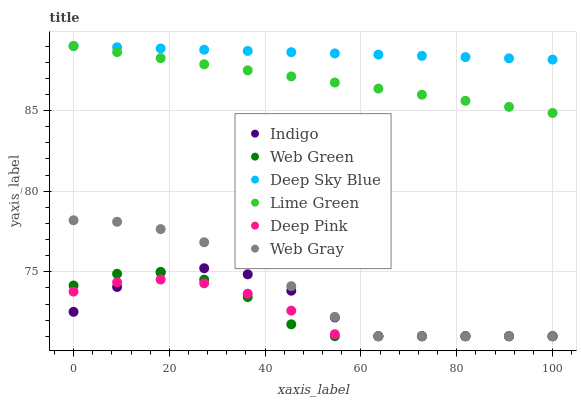Does Deep Pink have the minimum area under the curve?
Answer yes or no. Yes. Does Deep Sky Blue have the maximum area under the curve?
Answer yes or no. Yes. Does Indigo have the minimum area under the curve?
Answer yes or no. No. Does Indigo have the maximum area under the curve?
Answer yes or no. No. Is Deep Sky Blue the smoothest?
Answer yes or no. Yes. Is Indigo the roughest?
Answer yes or no. Yes. Is Web Green the smoothest?
Answer yes or no. No. Is Web Green the roughest?
Answer yes or no. No. Does Web Gray have the lowest value?
Answer yes or no. Yes. Does Deep Sky Blue have the lowest value?
Answer yes or no. No. Does Lime Green have the highest value?
Answer yes or no. Yes. Does Indigo have the highest value?
Answer yes or no. No. Is Web Green less than Deep Sky Blue?
Answer yes or no. Yes. Is Deep Sky Blue greater than Indigo?
Answer yes or no. Yes. Does Web Gray intersect Deep Pink?
Answer yes or no. Yes. Is Web Gray less than Deep Pink?
Answer yes or no. No. Is Web Gray greater than Deep Pink?
Answer yes or no. No. Does Web Green intersect Deep Sky Blue?
Answer yes or no. No. 